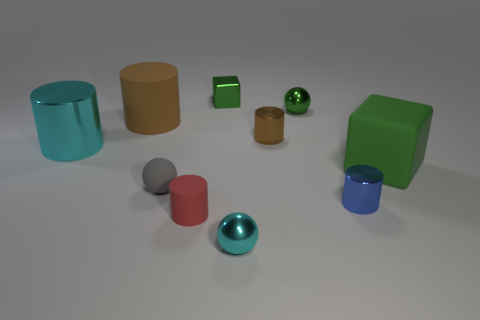How many other objects are the same shape as the large brown matte object?
Ensure brevity in your answer.  4. What is the size of the block to the right of the metal ball behind the large cyan shiny cylinder?
Give a very brief answer. Large. Do the cyan cylinder and the blue metallic cylinder have the same size?
Your answer should be very brief. No. There is a large cyan metal thing that is in front of the small metal sphere that is behind the gray rubber ball; is there a green metal ball on the left side of it?
Keep it short and to the point. No. The green metallic sphere has what size?
Make the answer very short. Small. What number of brown matte cylinders are the same size as the rubber cube?
Offer a terse response. 1. There is a small red object that is the same shape as the brown metal thing; what is it made of?
Provide a succinct answer. Rubber. There is a thing that is both to the left of the small rubber cylinder and behind the large cyan metallic object; what shape is it?
Your response must be concise. Cylinder. The cyan metallic thing to the right of the large shiny cylinder has what shape?
Give a very brief answer. Sphere. How many tiny things are both in front of the matte cube and behind the big brown rubber object?
Your answer should be very brief. 0. 